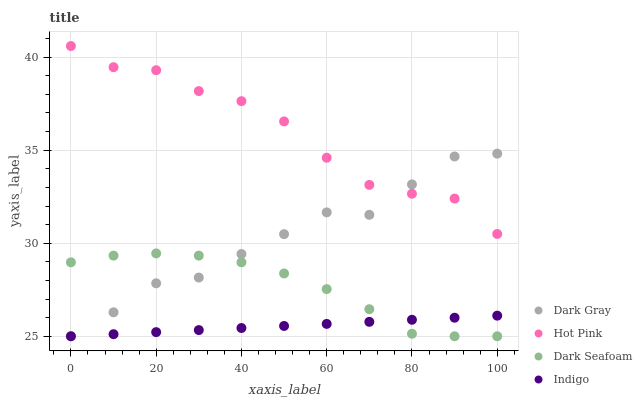Does Indigo have the minimum area under the curve?
Answer yes or no. Yes. Does Hot Pink have the maximum area under the curve?
Answer yes or no. Yes. Does Dark Seafoam have the minimum area under the curve?
Answer yes or no. No. Does Dark Seafoam have the maximum area under the curve?
Answer yes or no. No. Is Indigo the smoothest?
Answer yes or no. Yes. Is Dark Gray the roughest?
Answer yes or no. Yes. Is Dark Seafoam the smoothest?
Answer yes or no. No. Is Dark Seafoam the roughest?
Answer yes or no. No. Does Dark Gray have the lowest value?
Answer yes or no. Yes. Does Hot Pink have the lowest value?
Answer yes or no. No. Does Hot Pink have the highest value?
Answer yes or no. Yes. Does Dark Seafoam have the highest value?
Answer yes or no. No. Is Dark Seafoam less than Hot Pink?
Answer yes or no. Yes. Is Hot Pink greater than Dark Seafoam?
Answer yes or no. Yes. Does Dark Gray intersect Hot Pink?
Answer yes or no. Yes. Is Dark Gray less than Hot Pink?
Answer yes or no. No. Is Dark Gray greater than Hot Pink?
Answer yes or no. No. Does Dark Seafoam intersect Hot Pink?
Answer yes or no. No. 